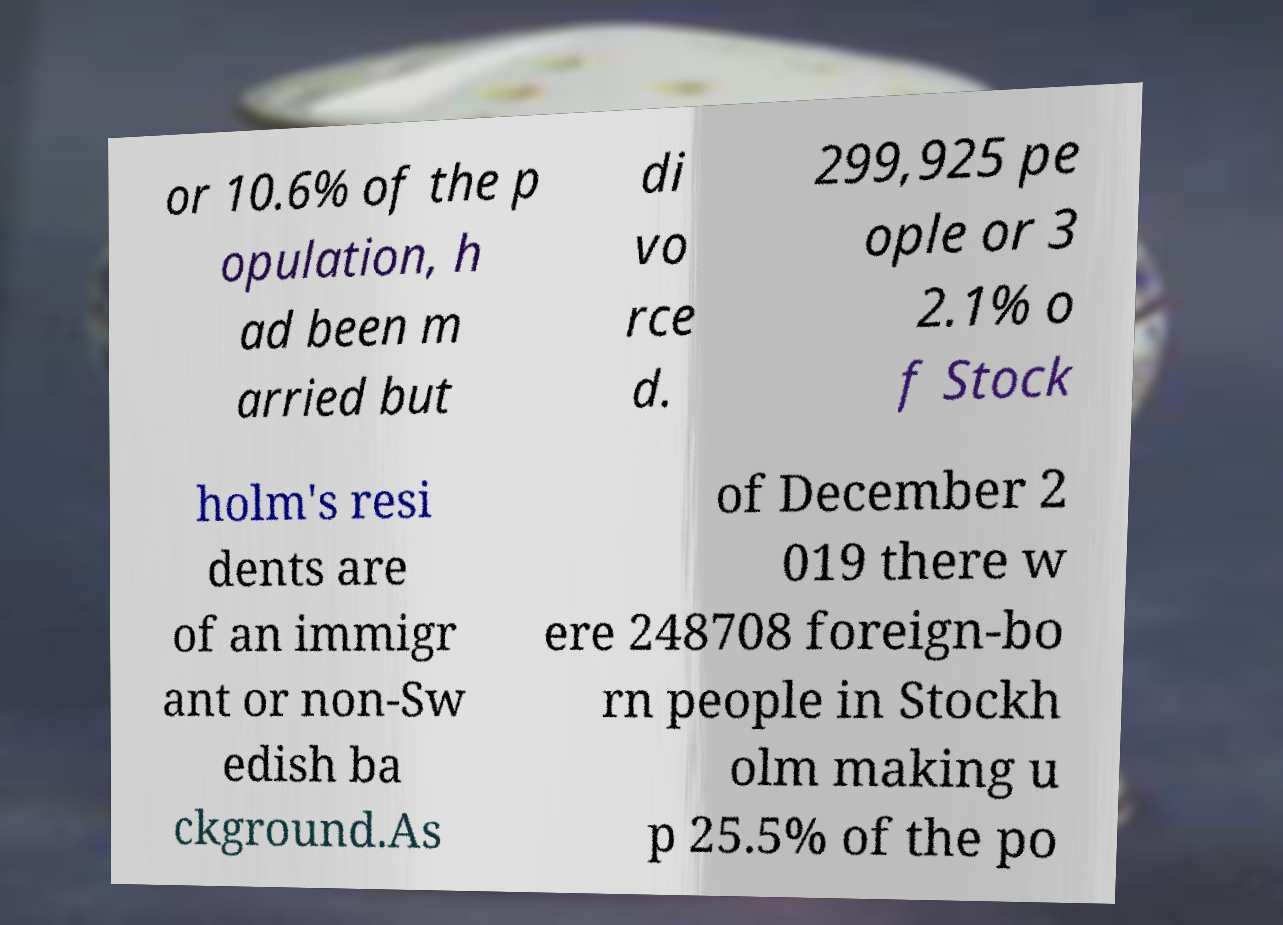For documentation purposes, I need the text within this image transcribed. Could you provide that? or 10.6% of the p opulation, h ad been m arried but di vo rce d. 299,925 pe ople or 3 2.1% o f Stock holm's resi dents are of an immigr ant or non-Sw edish ba ckground.As of December 2 019 there w ere 248708 foreign-bo rn people in Stockh olm making u p 25.5% of the po 